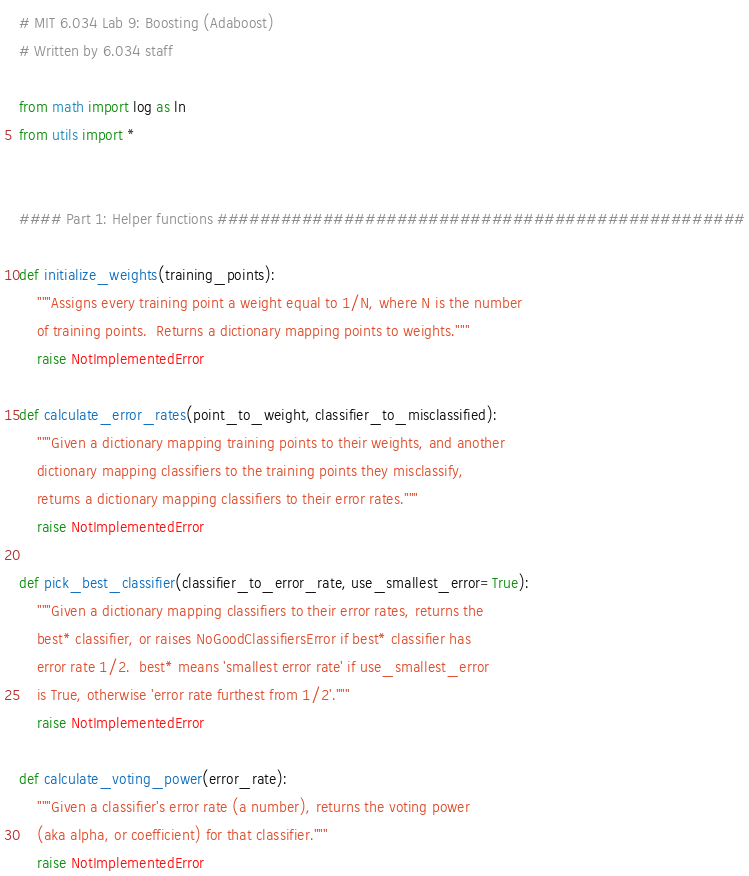<code> <loc_0><loc_0><loc_500><loc_500><_Python_># MIT 6.034 Lab 9: Boosting (Adaboost)
# Written by 6.034 staff

from math import log as ln
from utils import *


#### Part 1: Helper functions ##################################################

def initialize_weights(training_points):
    """Assigns every training point a weight equal to 1/N, where N is the number
    of training points.  Returns a dictionary mapping points to weights."""
    raise NotImplementedError

def calculate_error_rates(point_to_weight, classifier_to_misclassified):
    """Given a dictionary mapping training points to their weights, and another
    dictionary mapping classifiers to the training points they misclassify,
    returns a dictionary mapping classifiers to their error rates."""
    raise NotImplementedError

def pick_best_classifier(classifier_to_error_rate, use_smallest_error=True):
    """Given a dictionary mapping classifiers to their error rates, returns the
    best* classifier, or raises NoGoodClassifiersError if best* classifier has
    error rate 1/2.  best* means 'smallest error rate' if use_smallest_error
    is True, otherwise 'error rate furthest from 1/2'."""
    raise NotImplementedError

def calculate_voting_power(error_rate):
    """Given a classifier's error rate (a number), returns the voting power
    (aka alpha, or coefficient) for that classifier."""
    raise NotImplementedError
</code> 